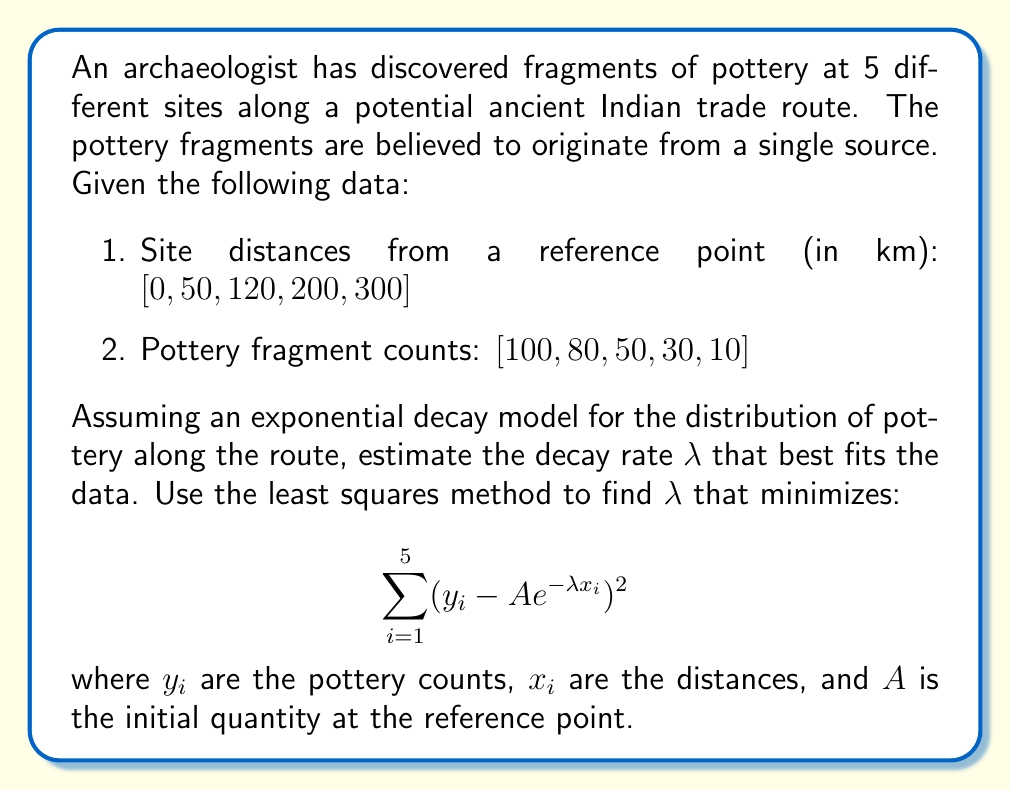Show me your answer to this math problem. To solve this inverse problem, we'll use the least squares method to estimate the decay rate $\lambda$. Here's a step-by-step approach:

1) First, we need to linearize the exponential model. Take the natural logarithm of both sides:
   $\ln(y) = \ln(A) - \lambda x$

2) Let $Y = \ln(y)$ and $b = \ln(A)$. Now we have a linear equation:
   $Y = b - \lambda x$

3) Calculate $Y_i = \ln(y_i)$ for each data point:
   $Y = [\ln(100), \ln(80), \ln(50), \ln(30), \ln(10)]$
   $Y \approx [4.61, 4.38, 3.91, 3.40, 2.30]$

4) Use the formula for the slope of the best-fit line:
   $$\lambda = \frac{n\sum x_iY_i - \sum x_i \sum Y_i}{n\sum x_i^2 - (\sum x_i)^2}$$

5) Calculate the necessary sums:
   $n = 5$
   $\sum x_i = 670$
   $\sum Y_i \approx 18.60$
   $\sum x_iY_i \approx 2789.00$
   $\sum x_i^2 = 149,000$

6) Substitute into the formula:
   $$\lambda = \frac{5(2789.00) - 670(18.60)}{5(149,000) - 670^2}$$

7) Solve:
   $$\lambda \approx 0.00741 \text{ km}^{-1}$$

This value of $\lambda$ minimizes the sum of squared errors in the linearized model, which approximates the least squares solution for the original exponential model.
Answer: $\lambda \approx 0.00741 \text{ km}^{-1}$ 